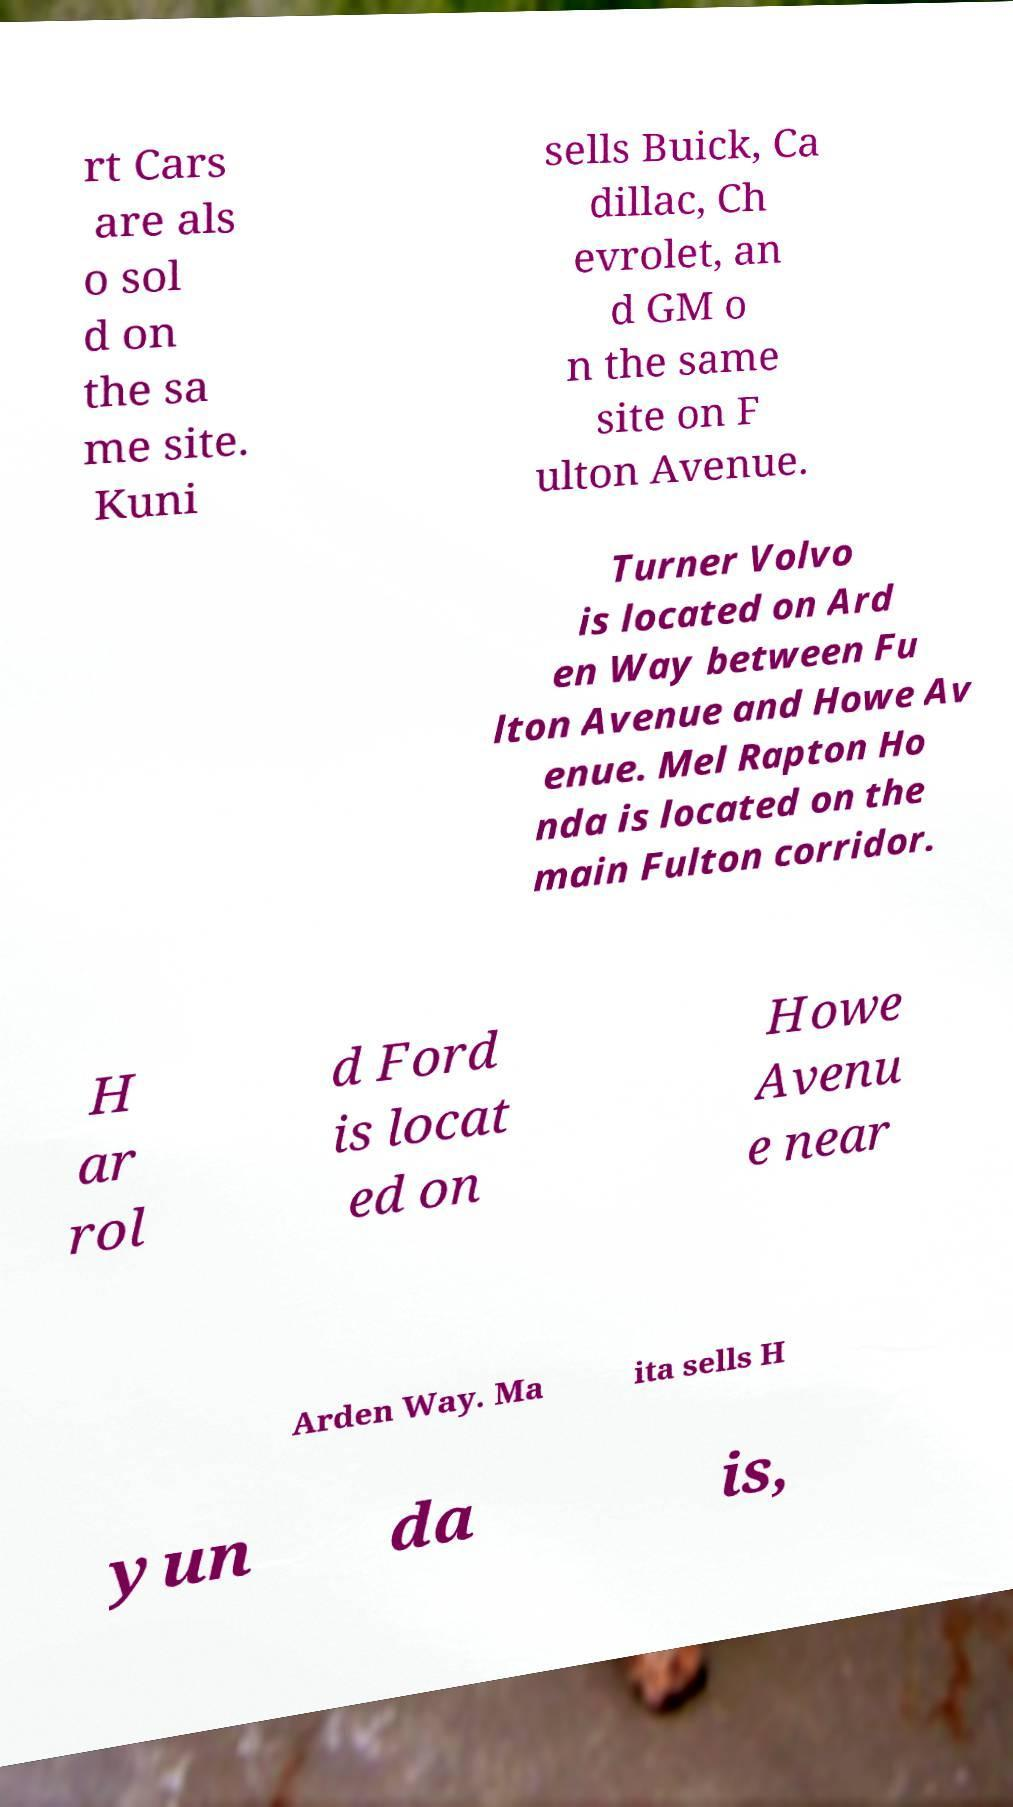Could you extract and type out the text from this image? rt Cars are als o sol d on the sa me site. Kuni sells Buick, Ca dillac, Ch evrolet, an d GM o n the same site on F ulton Avenue. Turner Volvo is located on Ard en Way between Fu lton Avenue and Howe Av enue. Mel Rapton Ho nda is located on the main Fulton corridor. H ar rol d Ford is locat ed on Howe Avenu e near Arden Way. Ma ita sells H yun da is, 